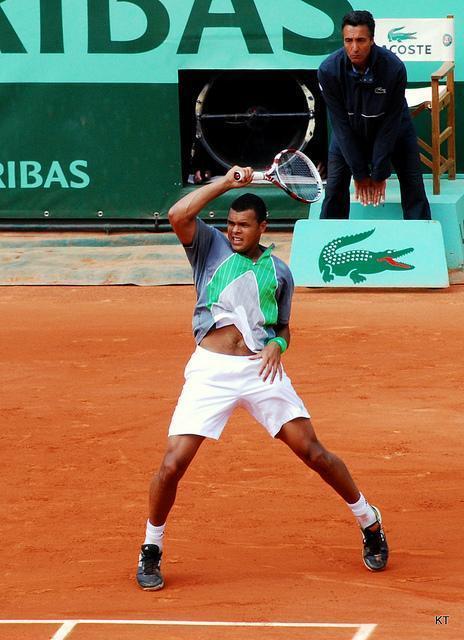How many people are seen?
Give a very brief answer. 2. How many people can be seen?
Give a very brief answer. 2. How many chairs are there?
Give a very brief answer. 2. 